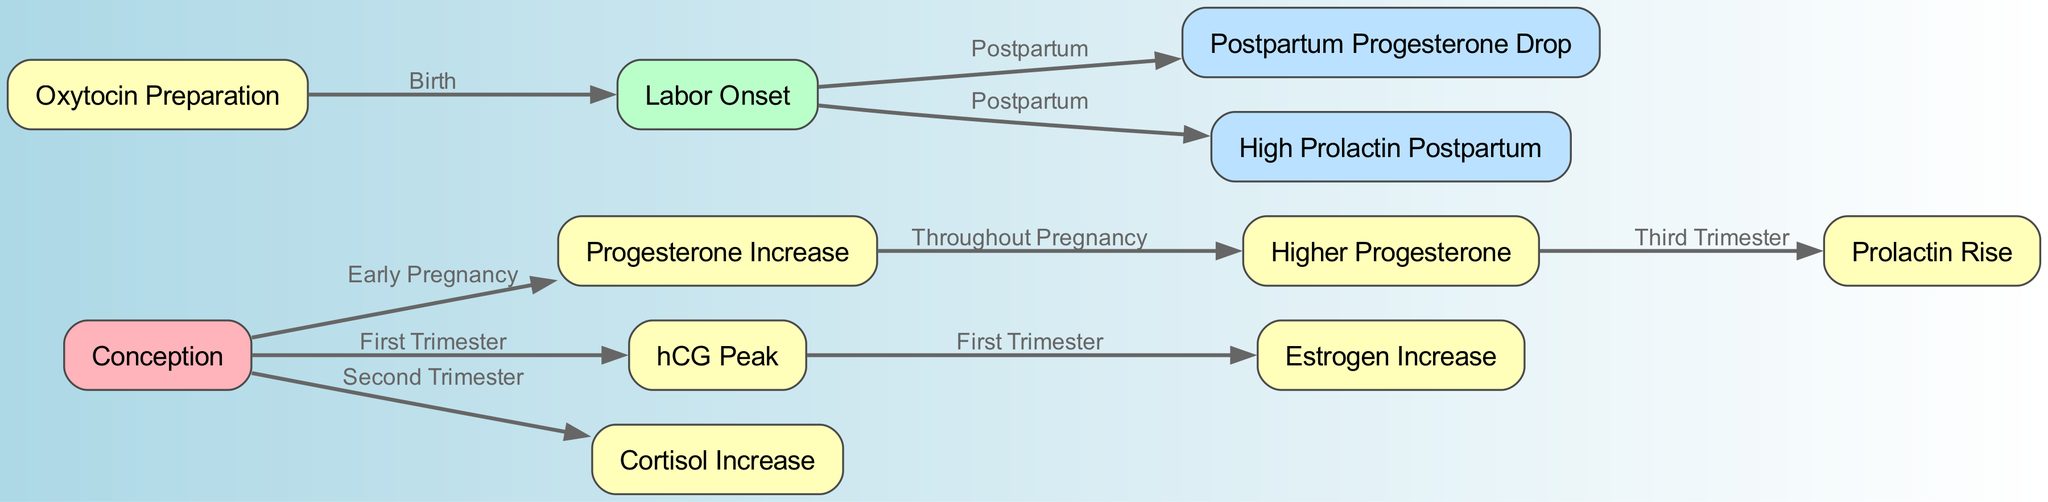What is the first hormone that increases after conception? The diagram shows "Progesterone Increase" as the first node connected to "Conception", indicating it is the first hormone that rises after conception.
Answer: Progesterone Increase How many primary nodes are depicted in the diagram? By counting the "nodes" listed in the data, there are a total of 11 distinct nodes representing various hormonal changes during pregnancy.
Answer: 11 Which hormone peaks during the first trimester? The node labeled "hCG Peak" is connected directly from "Conception" and is specified to occur in the first trimester according to the edges.
Answer: hCG Peak What change occurs during the third trimester related to prolactin? The diagram states that from "Higher Progesterone" there is an edge leading to "Prolactin Rise", indicating that prolactin levels increase in the third trimester.
Answer: Prolactin Rise Which hormone is associated with the onset of labor? The node "Labor Onset" is directly connected to "Oxytocin Preparation", indicating that oxytocin plays a key role in the onset of labor.
Answer: Oxytocin Preparation What hormone shows a drop postpartum? The diagram specifies the node "Postpartum Progesterone Drop," indicating that progesterone levels decrease after birth.
Answer: Postpartum Progesterone Drop During which trimester does cortisol begin to increase? The diagram indicates an edge labeled "Second Trimester" connecting "Conception" to "Cortisol Increase," indicating that cortisol begins to rise during the second trimester.
Answer: Second Trimester What hormone is elevated in the postpartum period? The edge from "Labor Onset" to "High Prolactin Postpartum" specifies that prolactin levels are high after birth.
Answer: High Prolactin Postpartum How are progesterone levels described throughout pregnancy? The arrows indicate that after "Progesterone Increase," it leads to "Higher Progesterone", suggesting that progesterone increases consistently during pregnancy.
Answer: Higher Progesterone 